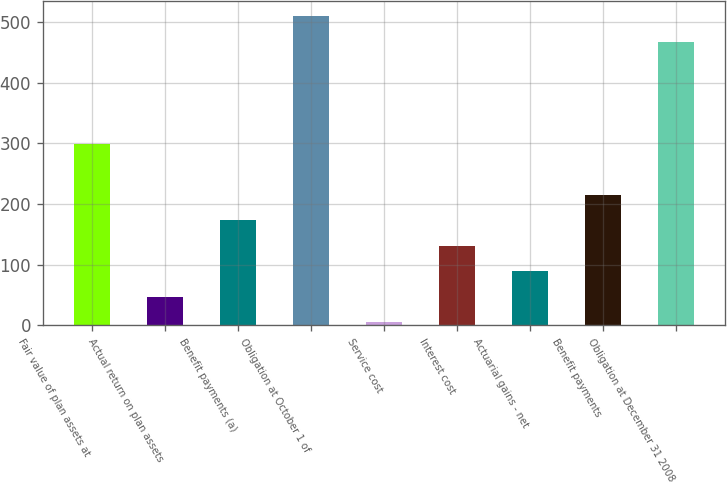Convert chart to OTSL. <chart><loc_0><loc_0><loc_500><loc_500><bar_chart><fcel>Fair value of plan assets at<fcel>Actual return on plan assets<fcel>Benefit payments (a)<fcel>Obligation at October 1 of<fcel>Service cost<fcel>Interest cost<fcel>Actuarial gains - net<fcel>Benefit payments<fcel>Obligation at December 31 2008<nl><fcel>299<fcel>47<fcel>173<fcel>509<fcel>5<fcel>131<fcel>89<fcel>215<fcel>467<nl></chart> 